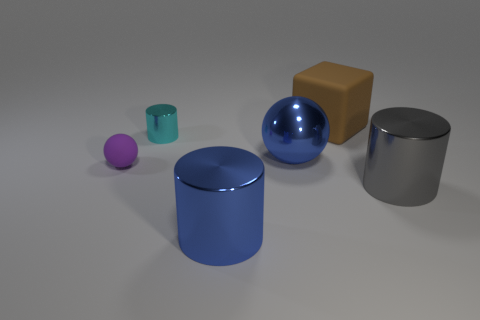There is a cylinder that is the same color as the big shiny ball; what is its material?
Your answer should be very brief. Metal. What is the size of the metal thing that is the same color as the big shiny ball?
Provide a short and direct response. Large. There is a object that is behind the small ball and on the right side of the blue metallic ball; what shape is it?
Offer a very short reply. Cube. How many other objects are the same shape as the small cyan object?
Ensure brevity in your answer.  2. How many objects are either shiny objects that are on the right side of the brown rubber cube or objects on the left side of the small shiny cylinder?
Your answer should be compact. 2. What number of other things are the same color as the large sphere?
Offer a terse response. 1. Are there fewer blue things in front of the small metal object than tiny spheres in front of the gray object?
Your answer should be very brief. No. What number of big blue things are there?
Provide a short and direct response. 2. Is there anything else that is the same material as the tiny purple ball?
Give a very brief answer. Yes. What is the material of the big blue thing that is the same shape as the large gray object?
Keep it short and to the point. Metal. 